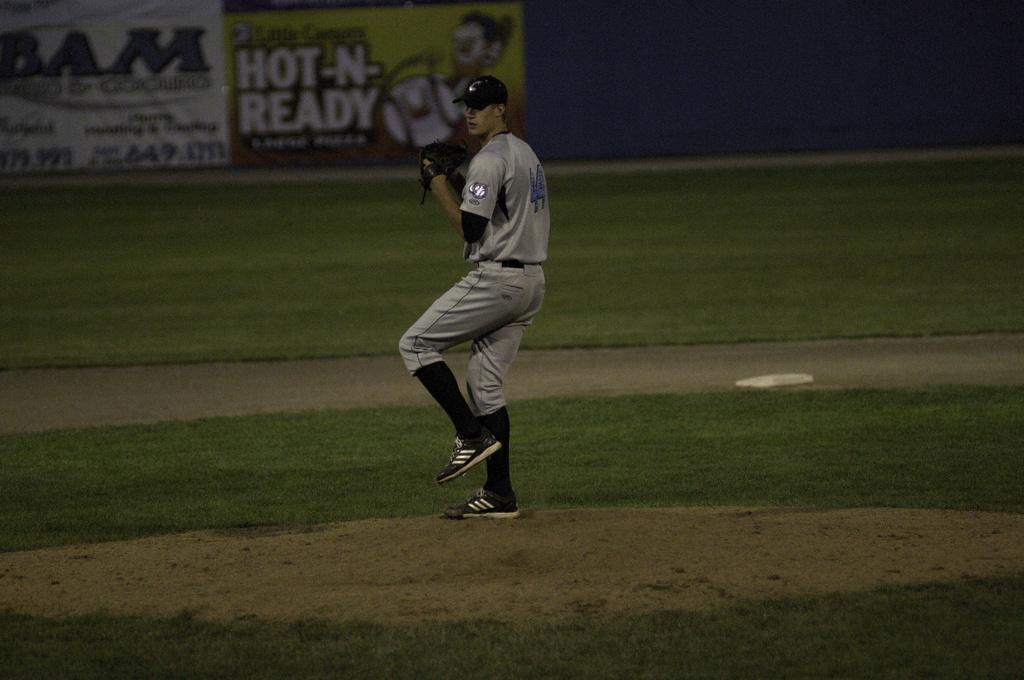Could you give a brief overview of what you see in this image? In this picture I can see there is a man standing, he is wearing a cap and gloves. There is soil, there's grass on the floor. 